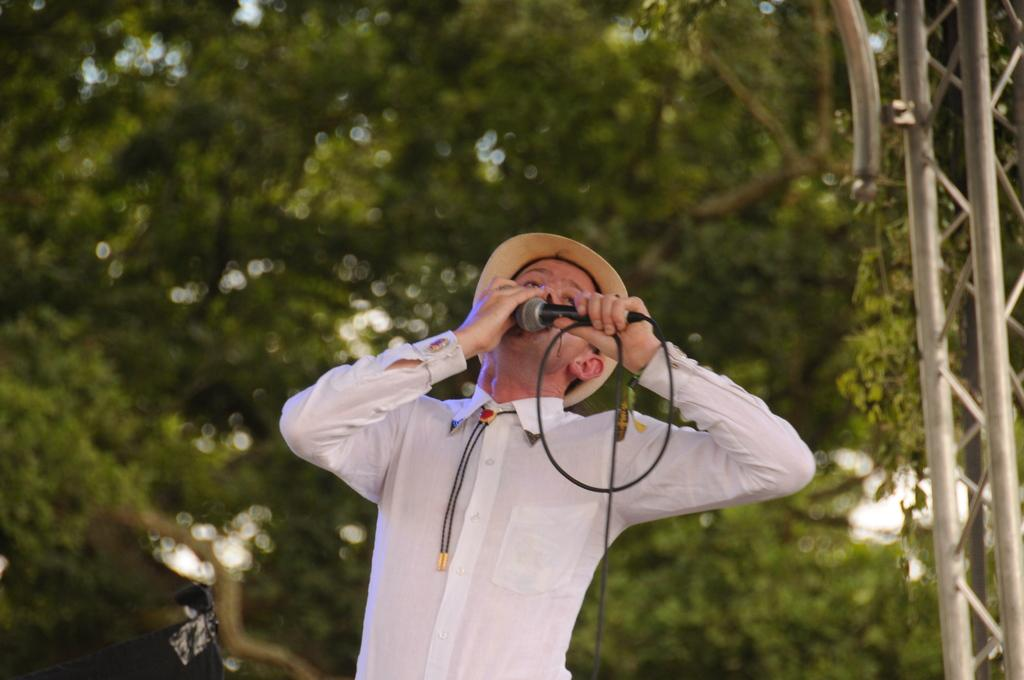What can be seen in the image? There is a person in the image. What is the person wearing? The person is wearing clothes and a hat. What is the person holding in their hands? The person is holding a microphone in their hands. What else is visible in the image? There is a cable wire in the image. How would you describe the background of the image? The background of the image is blurred. What type of linen is being used for the observation in the image? There is no linen or observation present in the image. What industry is depicted in the image? The image does not depict any specific industry; it features a person holding a microphone. 